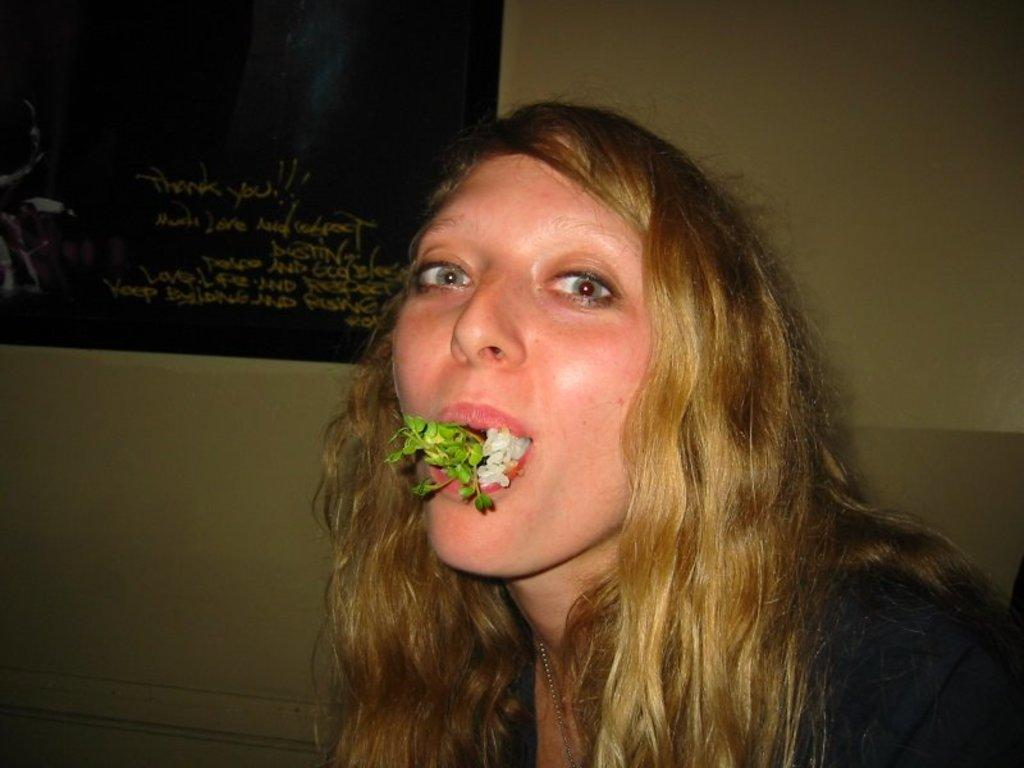Who is the main subject in the foreground of the image? There is a woman in the foreground of the image. What is the woman doing in the image? It appears that rice and leaves are in the woman's mouth. What can be seen in the background of the image? There is a wall in the background of the image. Is there any additional information about the wall in the background? There may be a poster at the top of the wall in the background. What type of neck accessory is the woman wearing in the image? There is no neck accessory visible in the image. Is there a hook hanging from the wall in the background? There is no hook visible in the image. 